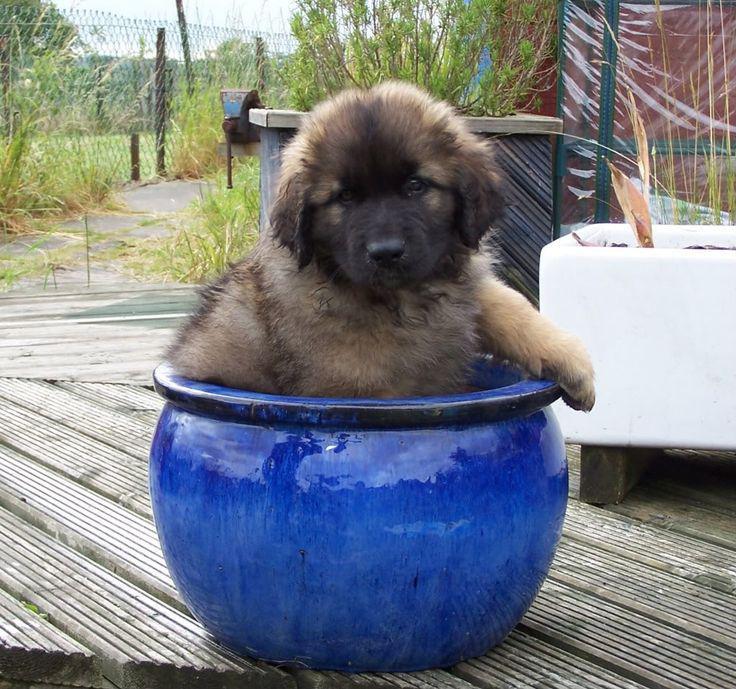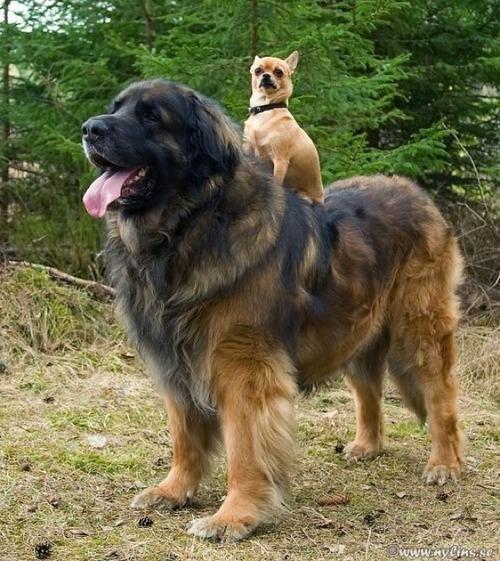The first image is the image on the left, the second image is the image on the right. Assess this claim about the two images: "There is one adult human in the image on the left". Correct or not? Answer yes or no. No. The first image is the image on the left, the second image is the image on the right. Analyze the images presented: Is the assertion "Only one image is of a dog with no people present." valid? Answer yes or no. No. 